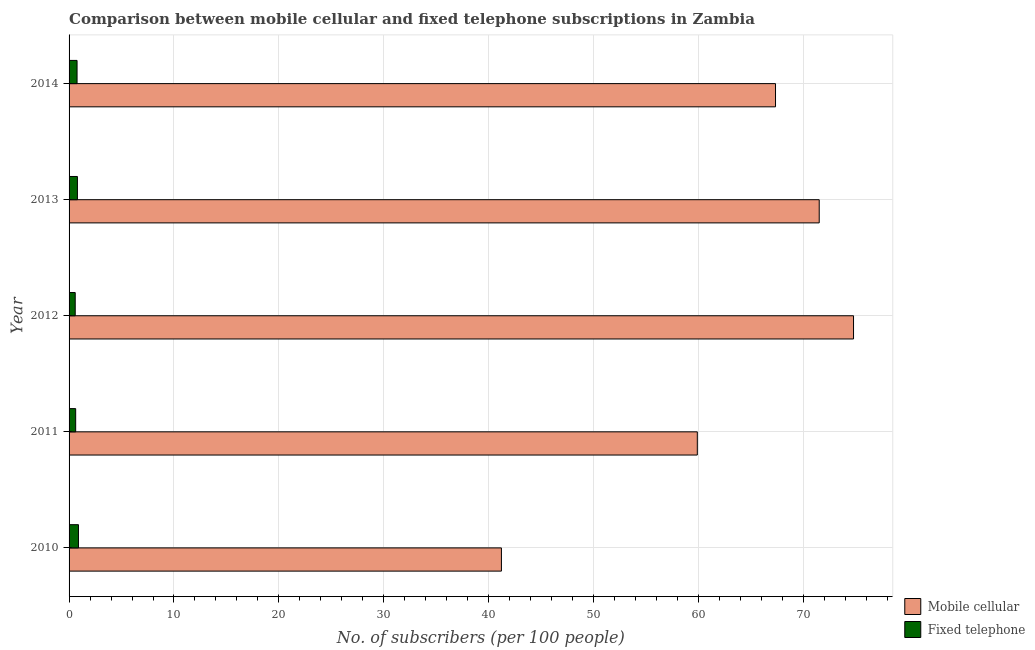How many groups of bars are there?
Provide a short and direct response. 5. Are the number of bars per tick equal to the number of legend labels?
Your answer should be compact. Yes. Are the number of bars on each tick of the Y-axis equal?
Ensure brevity in your answer.  Yes. How many bars are there on the 4th tick from the bottom?
Keep it short and to the point. 2. What is the label of the 2nd group of bars from the top?
Offer a very short reply. 2013. What is the number of fixed telephone subscribers in 2010?
Offer a very short reply. 0.9. Across all years, what is the maximum number of mobile cellular subscribers?
Provide a succinct answer. 74.78. Across all years, what is the minimum number of fixed telephone subscribers?
Keep it short and to the point. 0.59. In which year was the number of fixed telephone subscribers maximum?
Offer a terse response. 2010. In which year was the number of fixed telephone subscribers minimum?
Ensure brevity in your answer.  2012. What is the total number of mobile cellular subscribers in the graph?
Your response must be concise. 314.71. What is the difference between the number of fixed telephone subscribers in 2010 and that in 2013?
Offer a terse response. 0.1. What is the difference between the number of fixed telephone subscribers in 2010 and the number of mobile cellular subscribers in 2012?
Your answer should be very brief. -73.88. What is the average number of fixed telephone subscribers per year?
Give a very brief answer. 0.73. In the year 2010, what is the difference between the number of mobile cellular subscribers and number of fixed telephone subscribers?
Your response must be concise. 40.32. What is the ratio of the number of mobile cellular subscribers in 2010 to that in 2014?
Offer a terse response. 0.61. Is the difference between the number of fixed telephone subscribers in 2012 and 2013 greater than the difference between the number of mobile cellular subscribers in 2012 and 2013?
Give a very brief answer. No. What is the difference between the highest and the second highest number of fixed telephone subscribers?
Your answer should be very brief. 0.1. What is the difference between the highest and the lowest number of fixed telephone subscribers?
Offer a terse response. 0.31. In how many years, is the number of fixed telephone subscribers greater than the average number of fixed telephone subscribers taken over all years?
Make the answer very short. 3. Is the sum of the number of fixed telephone subscribers in 2012 and 2014 greater than the maximum number of mobile cellular subscribers across all years?
Make the answer very short. No. What does the 1st bar from the top in 2010 represents?
Offer a very short reply. Fixed telephone. What does the 2nd bar from the bottom in 2010 represents?
Provide a short and direct response. Fixed telephone. Are the values on the major ticks of X-axis written in scientific E-notation?
Keep it short and to the point. No. Does the graph contain grids?
Ensure brevity in your answer.  Yes. How many legend labels are there?
Provide a short and direct response. 2. How are the legend labels stacked?
Ensure brevity in your answer.  Vertical. What is the title of the graph?
Make the answer very short. Comparison between mobile cellular and fixed telephone subscriptions in Zambia. Does "State government" appear as one of the legend labels in the graph?
Provide a succinct answer. No. What is the label or title of the X-axis?
Give a very brief answer. No. of subscribers (per 100 people). What is the label or title of the Y-axis?
Your response must be concise. Year. What is the No. of subscribers (per 100 people) of Mobile cellular in 2010?
Your response must be concise. 41.21. What is the No. of subscribers (per 100 people) in Fixed telephone in 2010?
Give a very brief answer. 0.9. What is the No. of subscribers (per 100 people) in Mobile cellular in 2011?
Your response must be concise. 59.88. What is the No. of subscribers (per 100 people) of Fixed telephone in 2011?
Offer a very short reply. 0.63. What is the No. of subscribers (per 100 people) in Mobile cellular in 2012?
Provide a succinct answer. 74.78. What is the No. of subscribers (per 100 people) of Fixed telephone in 2012?
Provide a succinct answer. 0.59. What is the No. of subscribers (per 100 people) in Mobile cellular in 2013?
Give a very brief answer. 71.5. What is the No. of subscribers (per 100 people) in Fixed telephone in 2013?
Your response must be concise. 0.8. What is the No. of subscribers (per 100 people) in Mobile cellular in 2014?
Your response must be concise. 67.34. What is the No. of subscribers (per 100 people) of Fixed telephone in 2014?
Offer a very short reply. 0.76. Across all years, what is the maximum No. of subscribers (per 100 people) in Mobile cellular?
Give a very brief answer. 74.78. Across all years, what is the maximum No. of subscribers (per 100 people) in Fixed telephone?
Your answer should be compact. 0.9. Across all years, what is the minimum No. of subscribers (per 100 people) in Mobile cellular?
Make the answer very short. 41.21. Across all years, what is the minimum No. of subscribers (per 100 people) in Fixed telephone?
Ensure brevity in your answer.  0.59. What is the total No. of subscribers (per 100 people) of Mobile cellular in the graph?
Keep it short and to the point. 314.71. What is the total No. of subscribers (per 100 people) of Fixed telephone in the graph?
Your response must be concise. 3.67. What is the difference between the No. of subscribers (per 100 people) in Mobile cellular in 2010 and that in 2011?
Offer a terse response. -18.67. What is the difference between the No. of subscribers (per 100 people) of Fixed telephone in 2010 and that in 2011?
Give a very brief answer. 0.27. What is the difference between the No. of subscribers (per 100 people) of Mobile cellular in 2010 and that in 2012?
Offer a terse response. -33.56. What is the difference between the No. of subscribers (per 100 people) of Fixed telephone in 2010 and that in 2012?
Ensure brevity in your answer.  0.31. What is the difference between the No. of subscribers (per 100 people) in Mobile cellular in 2010 and that in 2013?
Provide a short and direct response. -30.29. What is the difference between the No. of subscribers (per 100 people) of Fixed telephone in 2010 and that in 2013?
Keep it short and to the point. 0.1. What is the difference between the No. of subscribers (per 100 people) in Mobile cellular in 2010 and that in 2014?
Provide a short and direct response. -26.13. What is the difference between the No. of subscribers (per 100 people) in Fixed telephone in 2010 and that in 2014?
Offer a terse response. 0.13. What is the difference between the No. of subscribers (per 100 people) of Mobile cellular in 2011 and that in 2012?
Provide a short and direct response. -14.89. What is the difference between the No. of subscribers (per 100 people) in Fixed telephone in 2011 and that in 2012?
Make the answer very short. 0.04. What is the difference between the No. of subscribers (per 100 people) of Mobile cellular in 2011 and that in 2013?
Provide a short and direct response. -11.62. What is the difference between the No. of subscribers (per 100 people) of Fixed telephone in 2011 and that in 2013?
Ensure brevity in your answer.  -0.17. What is the difference between the No. of subscribers (per 100 people) of Mobile cellular in 2011 and that in 2014?
Your answer should be compact. -7.45. What is the difference between the No. of subscribers (per 100 people) in Fixed telephone in 2011 and that in 2014?
Your response must be concise. -0.13. What is the difference between the No. of subscribers (per 100 people) in Mobile cellular in 2012 and that in 2013?
Provide a succinct answer. 3.27. What is the difference between the No. of subscribers (per 100 people) of Fixed telephone in 2012 and that in 2013?
Give a very brief answer. -0.21. What is the difference between the No. of subscribers (per 100 people) in Mobile cellular in 2012 and that in 2014?
Make the answer very short. 7.44. What is the difference between the No. of subscribers (per 100 people) in Fixed telephone in 2012 and that in 2014?
Your response must be concise. -0.18. What is the difference between the No. of subscribers (per 100 people) in Mobile cellular in 2013 and that in 2014?
Your answer should be very brief. 4.17. What is the difference between the No. of subscribers (per 100 people) in Fixed telephone in 2013 and that in 2014?
Your answer should be very brief. 0.03. What is the difference between the No. of subscribers (per 100 people) of Mobile cellular in 2010 and the No. of subscribers (per 100 people) of Fixed telephone in 2011?
Offer a very short reply. 40.58. What is the difference between the No. of subscribers (per 100 people) of Mobile cellular in 2010 and the No. of subscribers (per 100 people) of Fixed telephone in 2012?
Offer a terse response. 40.63. What is the difference between the No. of subscribers (per 100 people) in Mobile cellular in 2010 and the No. of subscribers (per 100 people) in Fixed telephone in 2013?
Make the answer very short. 40.42. What is the difference between the No. of subscribers (per 100 people) in Mobile cellular in 2010 and the No. of subscribers (per 100 people) in Fixed telephone in 2014?
Keep it short and to the point. 40.45. What is the difference between the No. of subscribers (per 100 people) of Mobile cellular in 2011 and the No. of subscribers (per 100 people) of Fixed telephone in 2012?
Offer a terse response. 59.3. What is the difference between the No. of subscribers (per 100 people) in Mobile cellular in 2011 and the No. of subscribers (per 100 people) in Fixed telephone in 2013?
Offer a terse response. 59.09. What is the difference between the No. of subscribers (per 100 people) in Mobile cellular in 2011 and the No. of subscribers (per 100 people) in Fixed telephone in 2014?
Keep it short and to the point. 59.12. What is the difference between the No. of subscribers (per 100 people) in Mobile cellular in 2012 and the No. of subscribers (per 100 people) in Fixed telephone in 2013?
Provide a short and direct response. 73.98. What is the difference between the No. of subscribers (per 100 people) of Mobile cellular in 2012 and the No. of subscribers (per 100 people) of Fixed telephone in 2014?
Your answer should be very brief. 74.01. What is the difference between the No. of subscribers (per 100 people) of Mobile cellular in 2013 and the No. of subscribers (per 100 people) of Fixed telephone in 2014?
Ensure brevity in your answer.  70.74. What is the average No. of subscribers (per 100 people) of Mobile cellular per year?
Your answer should be compact. 62.94. What is the average No. of subscribers (per 100 people) of Fixed telephone per year?
Keep it short and to the point. 0.73. In the year 2010, what is the difference between the No. of subscribers (per 100 people) in Mobile cellular and No. of subscribers (per 100 people) in Fixed telephone?
Keep it short and to the point. 40.32. In the year 2011, what is the difference between the No. of subscribers (per 100 people) of Mobile cellular and No. of subscribers (per 100 people) of Fixed telephone?
Keep it short and to the point. 59.26. In the year 2012, what is the difference between the No. of subscribers (per 100 people) in Mobile cellular and No. of subscribers (per 100 people) in Fixed telephone?
Provide a short and direct response. 74.19. In the year 2013, what is the difference between the No. of subscribers (per 100 people) in Mobile cellular and No. of subscribers (per 100 people) in Fixed telephone?
Your response must be concise. 70.71. In the year 2014, what is the difference between the No. of subscribers (per 100 people) of Mobile cellular and No. of subscribers (per 100 people) of Fixed telephone?
Give a very brief answer. 66.58. What is the ratio of the No. of subscribers (per 100 people) of Mobile cellular in 2010 to that in 2011?
Keep it short and to the point. 0.69. What is the ratio of the No. of subscribers (per 100 people) of Fixed telephone in 2010 to that in 2011?
Your response must be concise. 1.42. What is the ratio of the No. of subscribers (per 100 people) in Mobile cellular in 2010 to that in 2012?
Your response must be concise. 0.55. What is the ratio of the No. of subscribers (per 100 people) in Fixed telephone in 2010 to that in 2012?
Make the answer very short. 1.53. What is the ratio of the No. of subscribers (per 100 people) of Mobile cellular in 2010 to that in 2013?
Provide a short and direct response. 0.58. What is the ratio of the No. of subscribers (per 100 people) of Fixed telephone in 2010 to that in 2013?
Make the answer very short. 1.12. What is the ratio of the No. of subscribers (per 100 people) in Mobile cellular in 2010 to that in 2014?
Your answer should be very brief. 0.61. What is the ratio of the No. of subscribers (per 100 people) of Fixed telephone in 2010 to that in 2014?
Your answer should be very brief. 1.18. What is the ratio of the No. of subscribers (per 100 people) of Mobile cellular in 2011 to that in 2012?
Your response must be concise. 0.8. What is the ratio of the No. of subscribers (per 100 people) in Fixed telephone in 2011 to that in 2012?
Your response must be concise. 1.07. What is the ratio of the No. of subscribers (per 100 people) in Mobile cellular in 2011 to that in 2013?
Your answer should be compact. 0.84. What is the ratio of the No. of subscribers (per 100 people) of Fixed telephone in 2011 to that in 2013?
Ensure brevity in your answer.  0.79. What is the ratio of the No. of subscribers (per 100 people) of Mobile cellular in 2011 to that in 2014?
Ensure brevity in your answer.  0.89. What is the ratio of the No. of subscribers (per 100 people) of Fixed telephone in 2011 to that in 2014?
Your answer should be very brief. 0.83. What is the ratio of the No. of subscribers (per 100 people) in Mobile cellular in 2012 to that in 2013?
Provide a succinct answer. 1.05. What is the ratio of the No. of subscribers (per 100 people) in Fixed telephone in 2012 to that in 2013?
Provide a succinct answer. 0.74. What is the ratio of the No. of subscribers (per 100 people) of Mobile cellular in 2012 to that in 2014?
Your answer should be compact. 1.11. What is the ratio of the No. of subscribers (per 100 people) in Fixed telephone in 2012 to that in 2014?
Provide a succinct answer. 0.77. What is the ratio of the No. of subscribers (per 100 people) in Mobile cellular in 2013 to that in 2014?
Offer a very short reply. 1.06. What is the ratio of the No. of subscribers (per 100 people) in Fixed telephone in 2013 to that in 2014?
Offer a very short reply. 1.05. What is the difference between the highest and the second highest No. of subscribers (per 100 people) in Mobile cellular?
Your answer should be compact. 3.27. What is the difference between the highest and the second highest No. of subscribers (per 100 people) in Fixed telephone?
Provide a succinct answer. 0.1. What is the difference between the highest and the lowest No. of subscribers (per 100 people) of Mobile cellular?
Offer a very short reply. 33.56. What is the difference between the highest and the lowest No. of subscribers (per 100 people) in Fixed telephone?
Your answer should be compact. 0.31. 